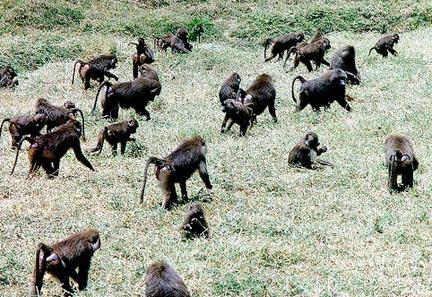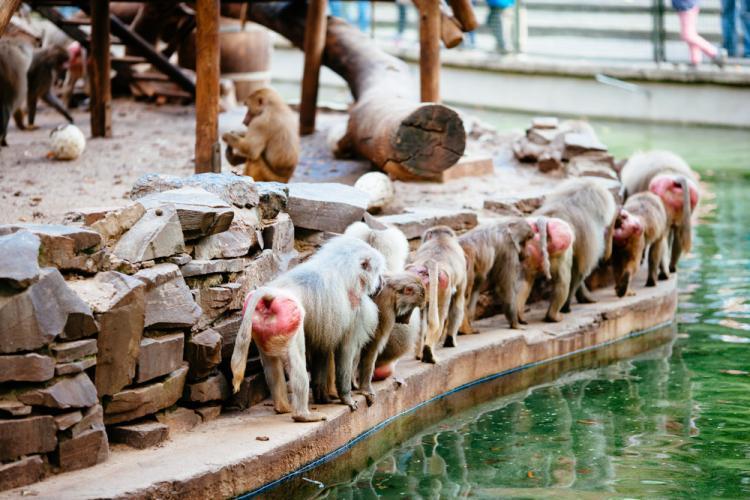The first image is the image on the left, the second image is the image on the right. Examine the images to the left and right. Is the description "One of the images contains no more than five monkeys" accurate? Answer yes or no. No. The first image is the image on the left, the second image is the image on the right. Considering the images on both sides, is "Multiple baboons sit on tiered rocks in at least one image." valid? Answer yes or no. No. 